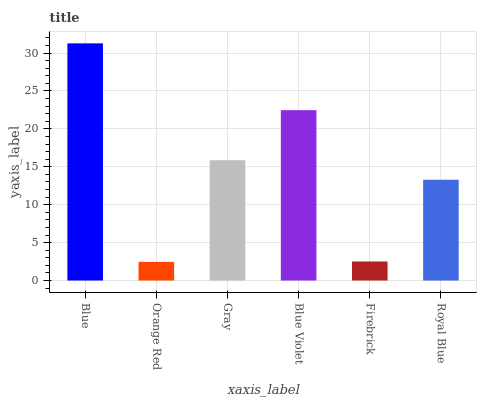Is Gray the minimum?
Answer yes or no. No. Is Gray the maximum?
Answer yes or no. No. Is Gray greater than Orange Red?
Answer yes or no. Yes. Is Orange Red less than Gray?
Answer yes or no. Yes. Is Orange Red greater than Gray?
Answer yes or no. No. Is Gray less than Orange Red?
Answer yes or no. No. Is Gray the high median?
Answer yes or no. Yes. Is Royal Blue the low median?
Answer yes or no. Yes. Is Firebrick the high median?
Answer yes or no. No. Is Blue Violet the low median?
Answer yes or no. No. 